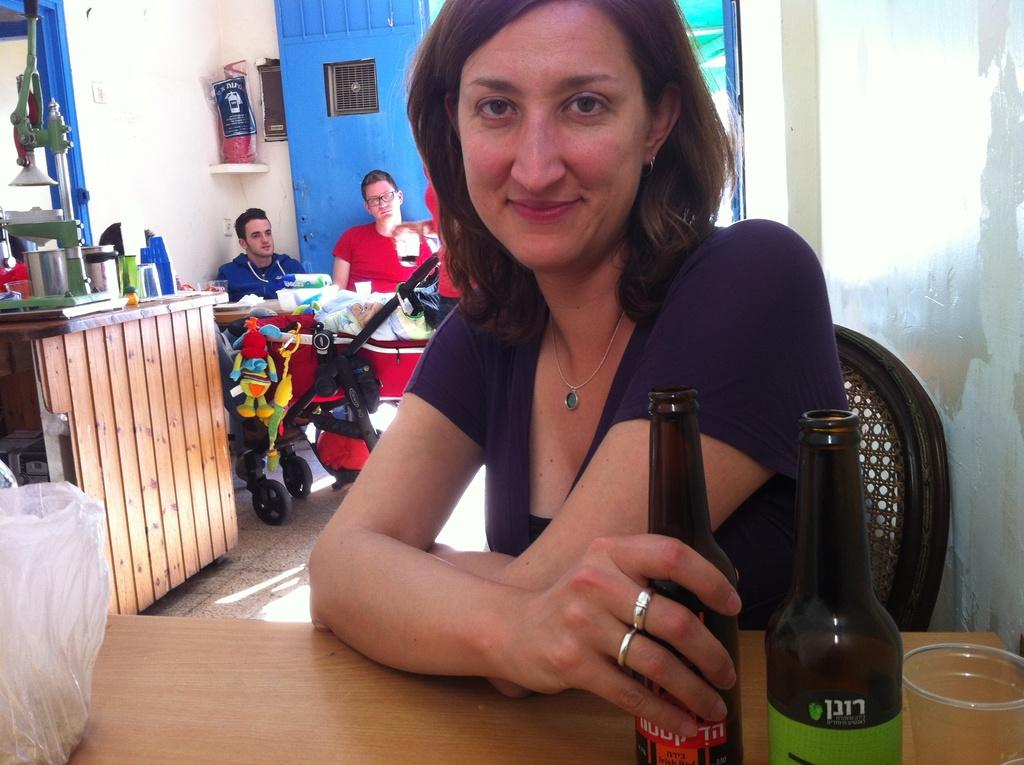What is the color of the wall in the image? The wall in the image is white. How many people are sitting in the image? There are three people sitting on chairs in the image. What is present in the image besides the people? There is a table, bottles, a cover, and a glass on the table. What type of pencil is the crow holding in the image? There is no crow or pencil present in the image. What emotion might the people be feeling in the image? The image does not convey any specific emotions, so it is not possible to determine how the people might be feeling. 